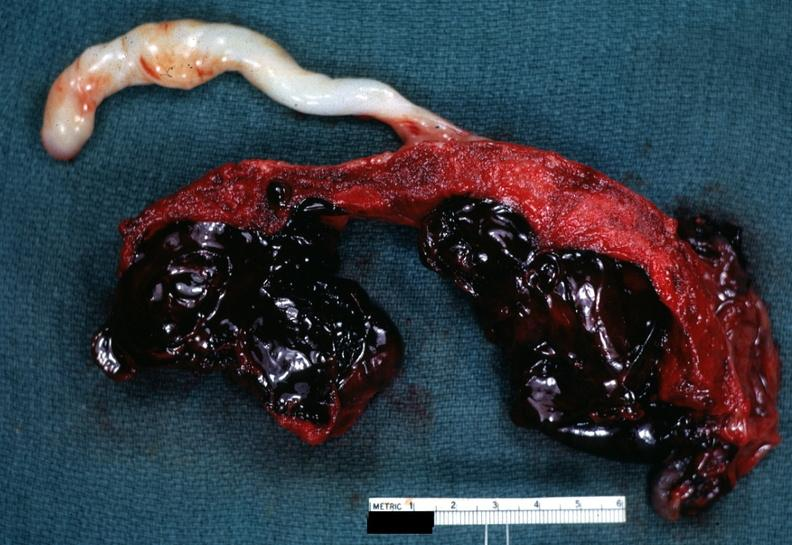where does this belong to?
Answer the question using a single word or phrase. Female reproductive system 